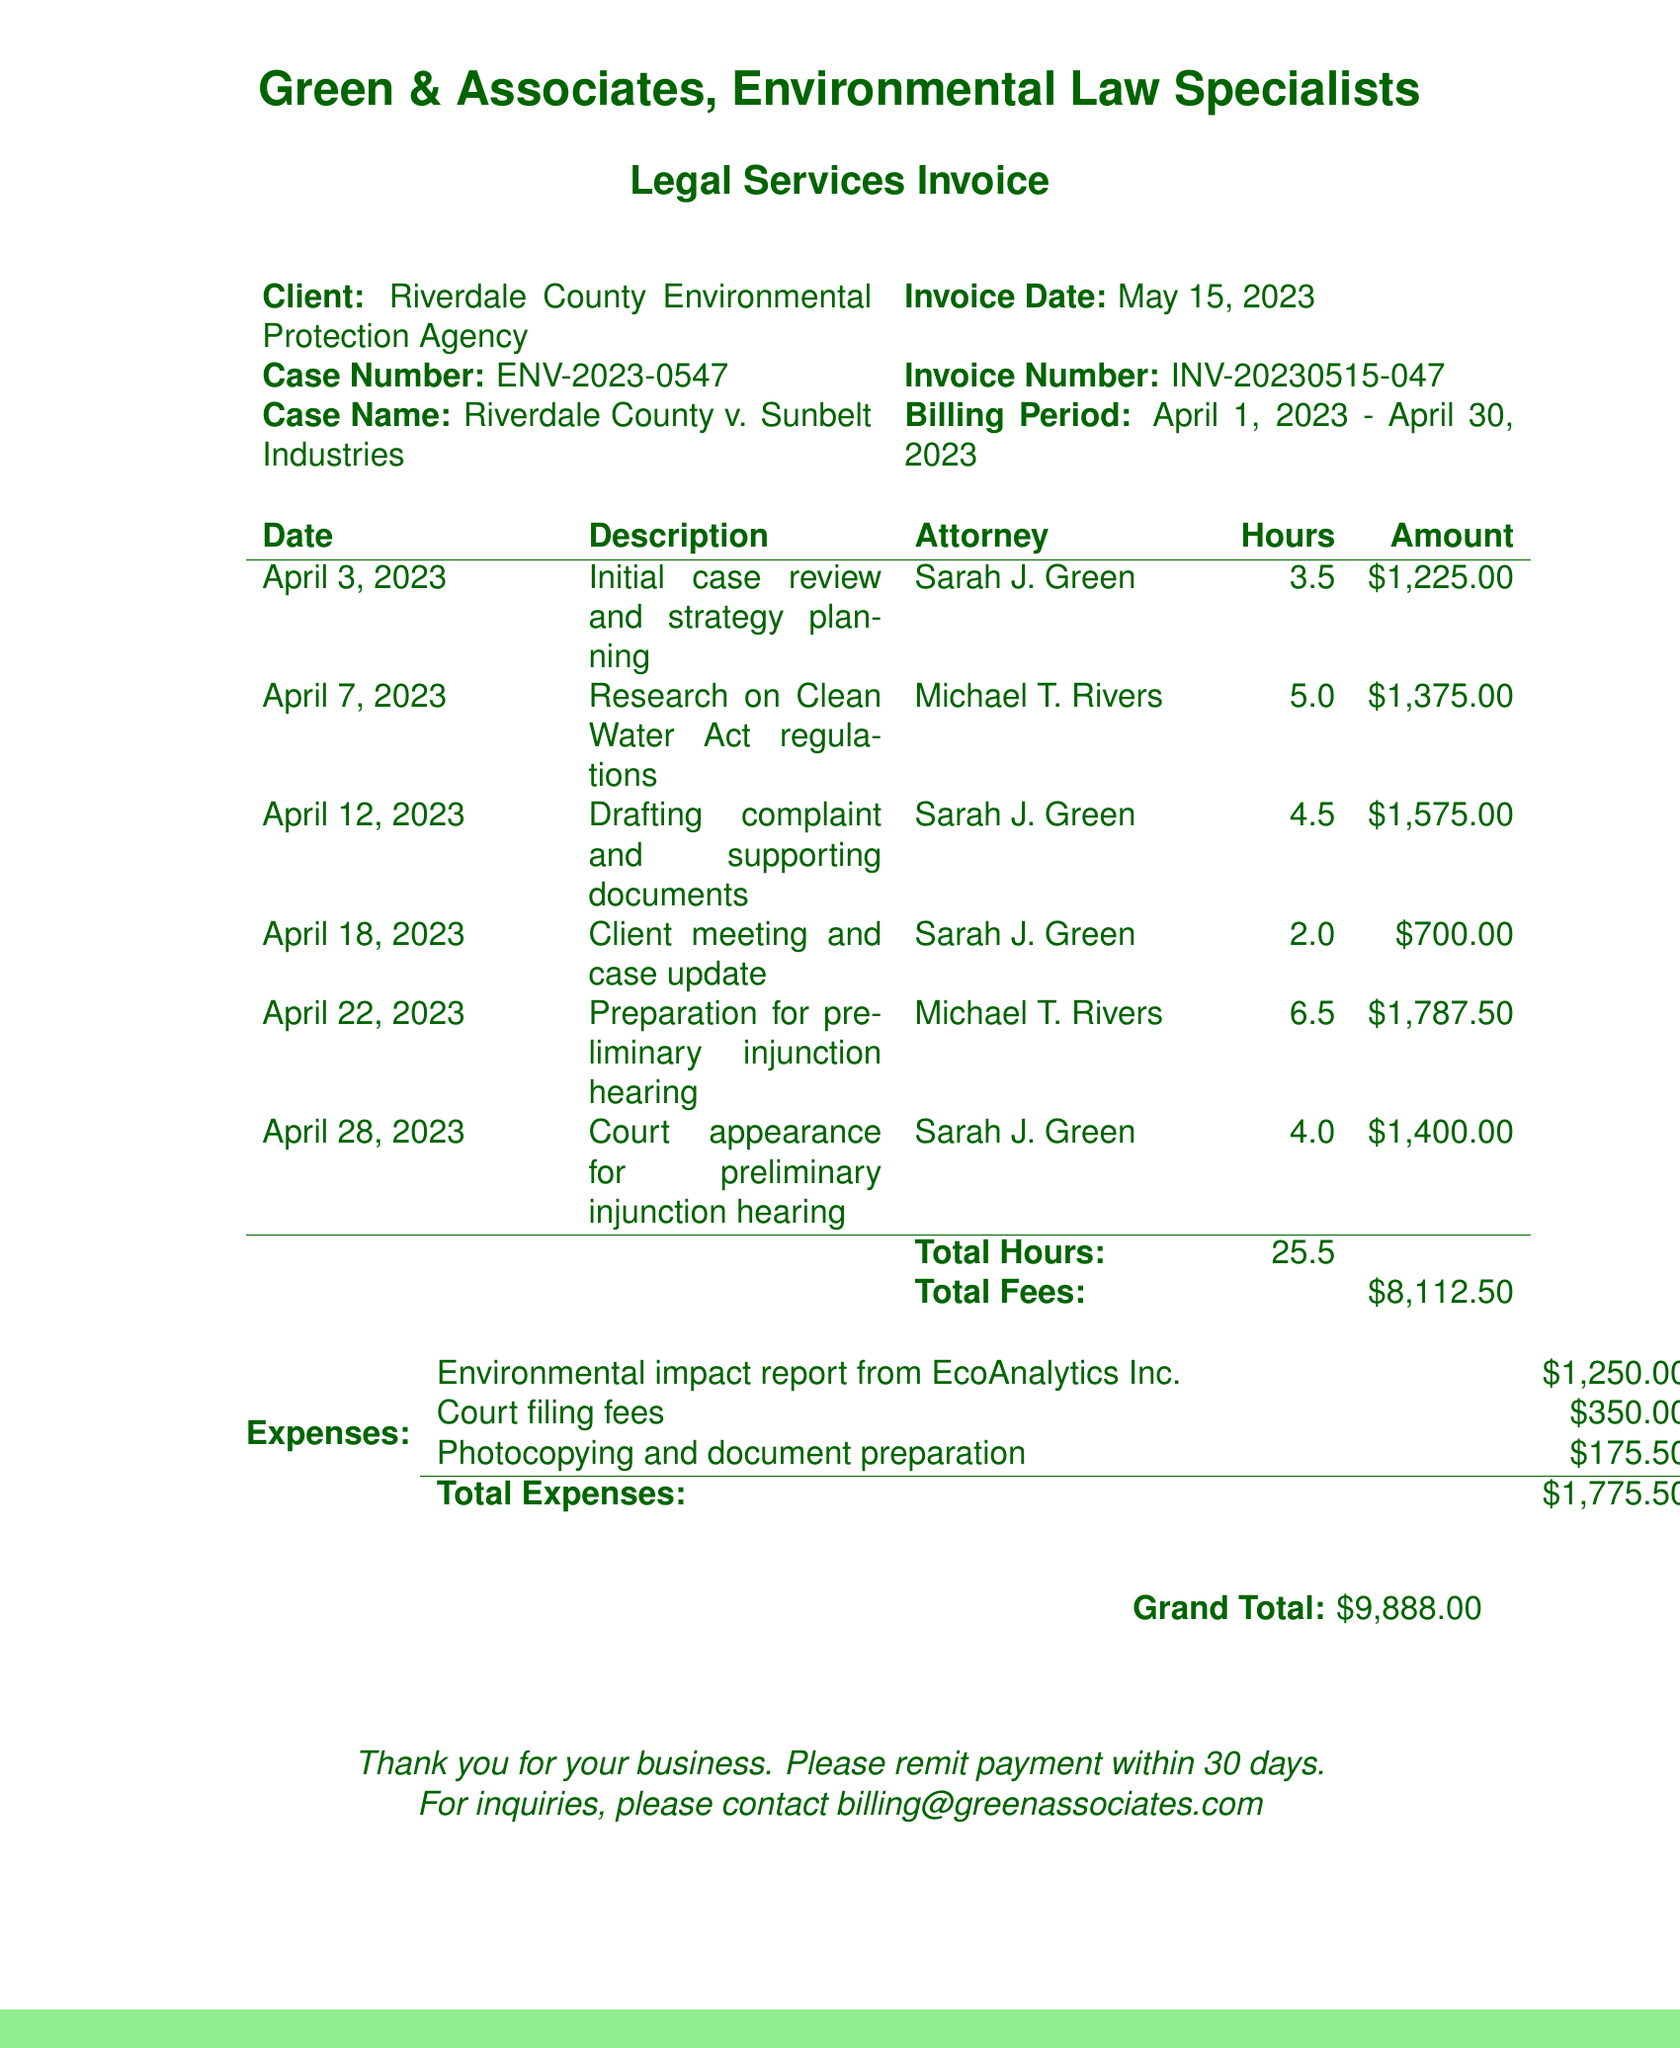What is the client name? The client name is specified at the top of the invoice, indicating who the services were provided for.
Answer: Riverdale County Environmental Protection Agency What is the invoice date? The invoice date is listed in the document to indicate when the invoice was issued.
Answer: May 15, 2023 What is the case number? The case number helps to identify the specific legal case for which the services were rendered.
Answer: ENV-2023-0547 Who worked the most hours on this case? The attorney who logged the highest number of hours is noted in the billing table.
Answer: Michael T. Rivers What was the total amount billed for attorney hours? The total amount can be calculated by summing the fees associated with attorney hours listed in the invoice.
Answer: $8,112.50 What was the highest individual expense listed? The highest expense helps to understand significant costs related to the case, outlined in the expenses section.
Answer: Environmental impact report from EcoAnalytics Inc What is the total number of hours worked? The total hours worked are summed from the hours listed for each attorney's efforts on the case.
Answer: 25.5 What is the grand total of the invoice? The grand total is the overall amount that the client needs to pay, including fees and expenses.
Answer: $9,888.00 How many court appearances are listed in the invoice? The number of court appearances summarizes the involvement in court as documented in the billing table.
Answer: 1 